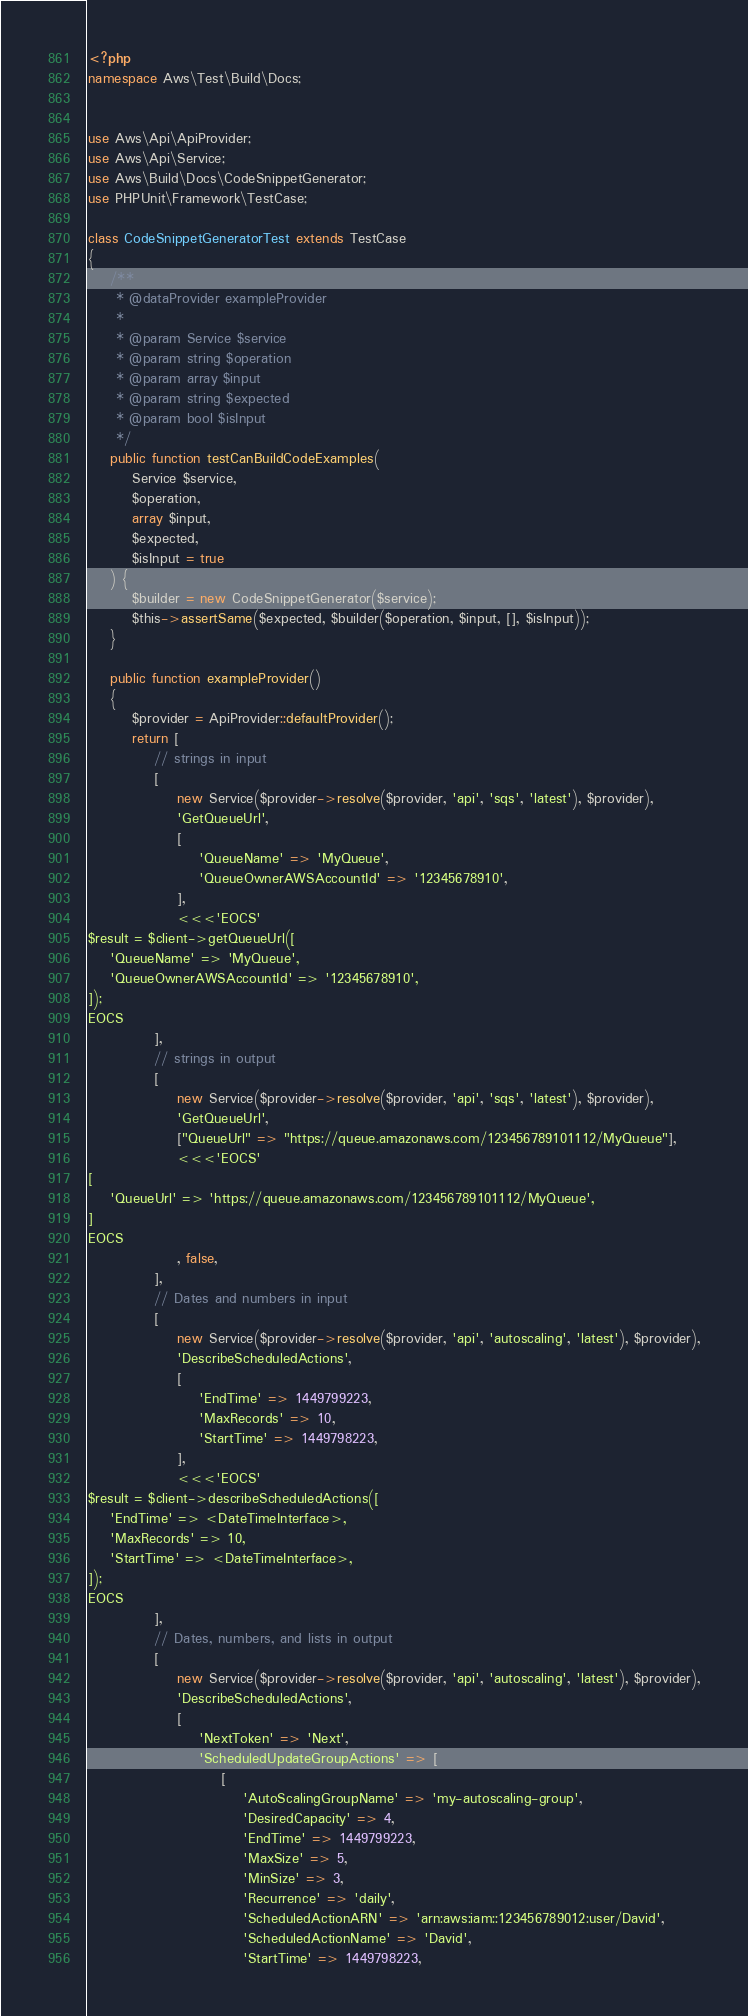<code> <loc_0><loc_0><loc_500><loc_500><_PHP_><?php
namespace Aws\Test\Build\Docs;


use Aws\Api\ApiProvider;
use Aws\Api\Service;
use Aws\Build\Docs\CodeSnippetGenerator;
use PHPUnit\Framework\TestCase;

class CodeSnippetGeneratorTest extends TestCase
{
    /**
     * @dataProvider exampleProvider
     *
     * @param Service $service
     * @param string $operation
     * @param array $input
     * @param string $expected
     * @param bool $isInput
     */
    public function testCanBuildCodeExamples(
        Service $service,
        $operation,
        array $input,
        $expected,
        $isInput = true
    ) {
        $builder = new CodeSnippetGenerator($service);
        $this->assertSame($expected, $builder($operation, $input, [], $isInput));
    }

    public function exampleProvider()
    {
        $provider = ApiProvider::defaultProvider();
        return [
            // strings in input
            [
                new Service($provider->resolve($provider, 'api', 'sqs', 'latest'), $provider),
                'GetQueueUrl',
                [
                    'QueueName' => 'MyQueue',
                    'QueueOwnerAWSAccountId' => '12345678910',
                ],
                <<<'EOCS'
$result = $client->getQueueUrl([
    'QueueName' => 'MyQueue',
    'QueueOwnerAWSAccountId' => '12345678910',
]);
EOCS
            ],
            // strings in output
            [
                new Service($provider->resolve($provider, 'api', 'sqs', 'latest'), $provider),
                'GetQueueUrl',
                ["QueueUrl" => "https://queue.amazonaws.com/123456789101112/MyQueue"],
                <<<'EOCS'
[
    'QueueUrl' => 'https://queue.amazonaws.com/123456789101112/MyQueue',
]
EOCS
                , false,
            ],
            // Dates and numbers in input
            [
                new Service($provider->resolve($provider, 'api', 'autoscaling', 'latest'), $provider),
                'DescribeScheduledActions',
                [
                    'EndTime' => 1449799223,
                    'MaxRecords' => 10,
                    'StartTime' => 1449798223,
                ],
                <<<'EOCS'
$result = $client->describeScheduledActions([
    'EndTime' => <DateTimeInterface>,
    'MaxRecords' => 10,
    'StartTime' => <DateTimeInterface>,
]);
EOCS
            ],
            // Dates, numbers, and lists in output
            [
                new Service($provider->resolve($provider, 'api', 'autoscaling', 'latest'), $provider),
                'DescribeScheduledActions',
                [
                    'NextToken' => 'Next',
                    'ScheduledUpdateGroupActions' => [
                        [
                            'AutoScalingGroupName' => 'my-autoscaling-group',
                            'DesiredCapacity' => 4,
                            'EndTime' => 1449799223,
                            'MaxSize' => 5,
                            'MinSize' => 3,
                            'Recurrence' => 'daily',
                            'ScheduledActionARN' => 'arn:aws:iam::123456789012:user/David',
                            'ScheduledActionName' => 'David',
                            'StartTime' => 1449798223,</code> 